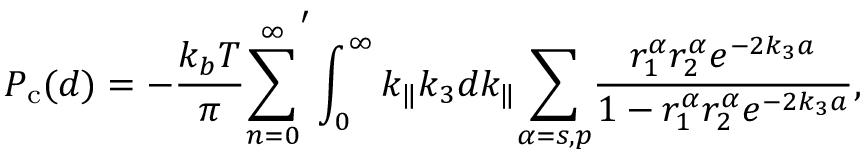Convert formula to latex. <formula><loc_0><loc_0><loc_500><loc_500>P _ { c } ( d ) = - \frac { k _ { b } T } { \pi } \overset { \infty } { \underset { n = 0 } { \sum } } ^ { \prime } \int _ { 0 } ^ { \infty } k _ { \| } k _ { 3 } d k _ { \| } \underset { \alpha = s , p } { \sum } \frac { r _ { 1 } ^ { \alpha } r _ { 2 } ^ { \alpha } e ^ { - 2 k _ { 3 } a } } { 1 - r _ { 1 } ^ { \alpha } r _ { 2 } ^ { \alpha } e ^ { - 2 k _ { 3 } a } } ,</formula> 